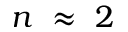<formula> <loc_0><loc_0><loc_500><loc_500>n \ \approx \ 2</formula> 